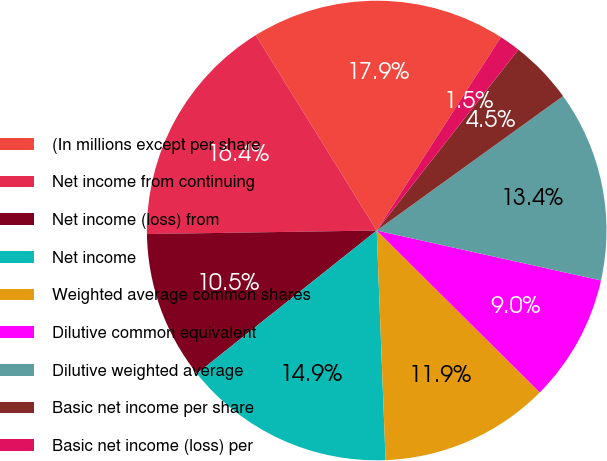<chart> <loc_0><loc_0><loc_500><loc_500><pie_chart><fcel>(In millions except per share<fcel>Net income from continuing<fcel>Net income (loss) from<fcel>Net income<fcel>Weighted average common shares<fcel>Dilutive common equivalent<fcel>Dilutive weighted average<fcel>Basic net income per share<fcel>Basic net income (loss) per<nl><fcel>17.91%<fcel>16.42%<fcel>10.45%<fcel>14.92%<fcel>11.94%<fcel>8.96%<fcel>13.43%<fcel>4.48%<fcel>1.49%<nl></chart> 